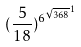<formula> <loc_0><loc_0><loc_500><loc_500>( \frac { 5 } { 1 8 } ) ^ { { 6 ^ { \sqrt { 3 6 8 } } } ^ { 1 } }</formula> 